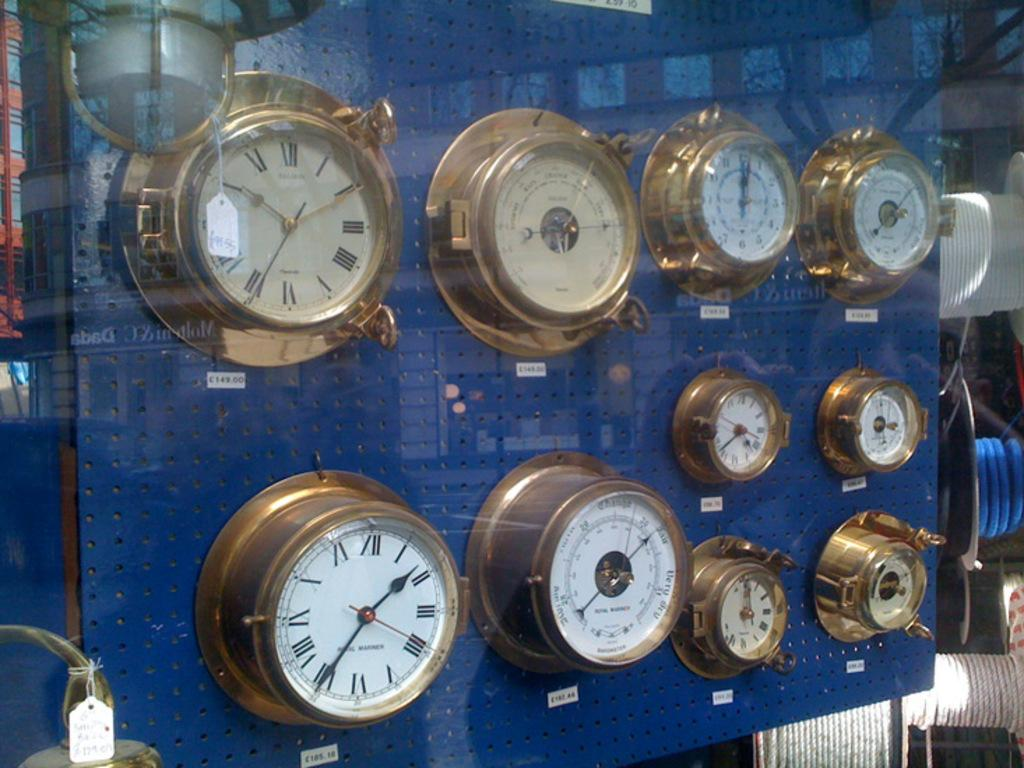<image>
Write a terse but informative summary of the picture. Old fashioned clocks on display for sale in British pounds for 149.00 and 185.18 